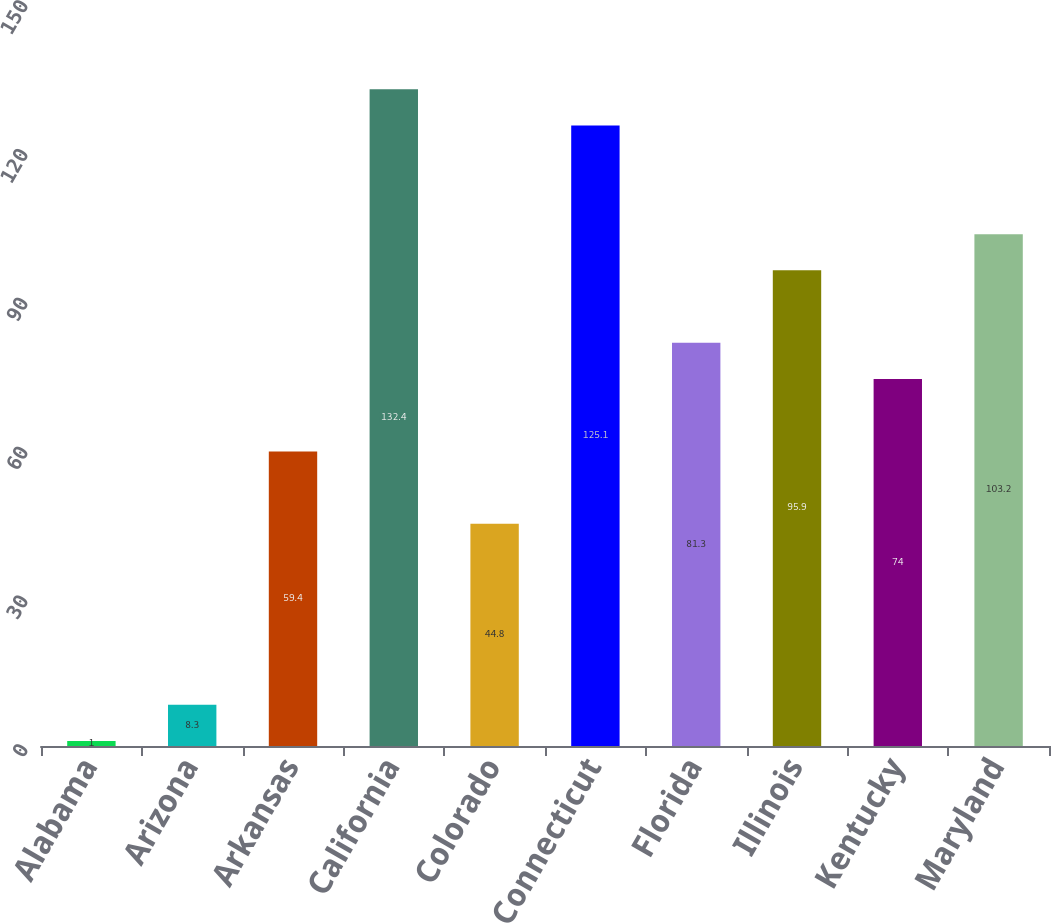<chart> <loc_0><loc_0><loc_500><loc_500><bar_chart><fcel>Alabama<fcel>Arizona<fcel>Arkansas<fcel>California<fcel>Colorado<fcel>Connecticut<fcel>Florida<fcel>Illinois<fcel>Kentucky<fcel>Maryland<nl><fcel>1<fcel>8.3<fcel>59.4<fcel>132.4<fcel>44.8<fcel>125.1<fcel>81.3<fcel>95.9<fcel>74<fcel>103.2<nl></chart> 